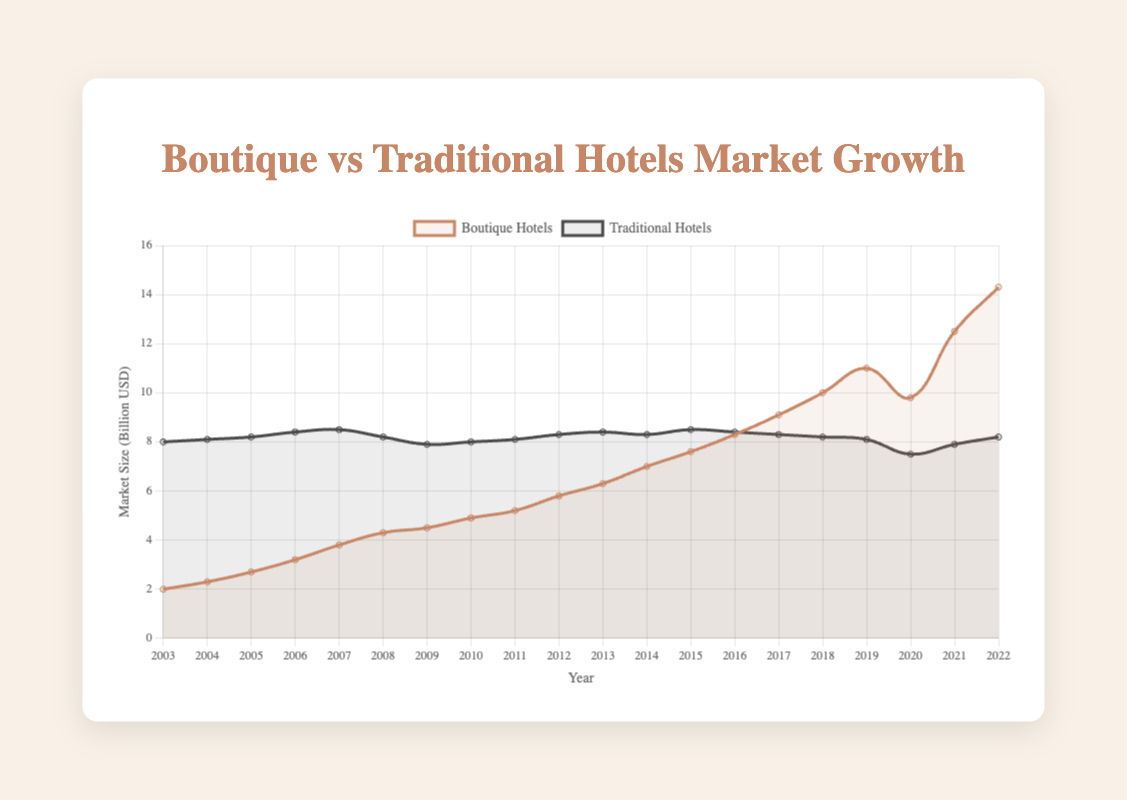What was the market size of boutique hotels in 2022? Referring to the plot, the data point for boutique hotels in 2022 shows a market size value.
Answer: 14.3 billion USD How has the market size of traditional hotels changed from 2003 to 2022? Observing the trend line for traditional hotels, note the market sizes in 2003 (8.0 billion USD) and 2022 (8.2 billion USD). Calculate the difference: 8.2 - 8.0.
Answer: Increased by 0.2 billion USD In which year did boutique hotels see the largest year-over-year growth in market size? Examine the year-to-year growth increments on the boutique hotel trend line and identify the largest change. The year-over-year growth from 2021 (12.5 billion USD) to 2022 (14.3 billion USD) is the largest.
Answer: 2022 Compare the market size of boutique hotels and traditional hotels in 2021. Look at the market sizes in 2021 for both types of hotels. Boutique hotels are at 12.5 billion USD, and traditional hotels are at 7.9 billion USD.
Answer: Boutique hotels had a larger market size Which type of hotel had a relatively stable market size from 2003 to 2022? Analyze both trend lines. Traditional hotels have maintained a more stable market size ranging between 7.5 and 8.5 billion USD, whereas boutique hotels show significant growth.
Answer: Traditional hotels Calculate the average annual growth rate of boutique hotels from 2003 (2.0 billion USD) to 2022 (14.3 billion USD). Find the total growth (14.3 - 2.0 = 12.3 billion USD) and divide by the number of years (2022 - 2003 = 19). 12.3 / 19.
Answer: Approximately 0.65 billion USD/year During which years did traditional hotels experience a decrease in market size? Observe the traditional hotels trend line for years where the market size values drop. Noticeable decreases occur from 2007 to 2008 and 2019 to 2020.
Answer: 2008 and 2020 What is the difference in market size between boutique and traditional hotels in 2018? Refer to the data points in 2018: boutique hotels (10.0 billion USD) and traditional hotels (8.2 billion USD). Calculate the difference: 10.0 - 8.2.
Answer: 1.8 billion USD Which hotel type shows a more pronounced upward trend in market size over the years? By comparing the slopes of the trend lines, boutique hotels show a more pronounced upward trend increasing from 2.0 to 14.3 billion USD, whereas traditional hotels remain relatively flat.
Answer: Boutique hotels 